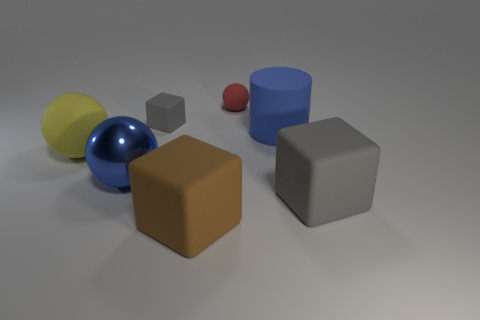Does the block that is to the right of the brown block have the same size as the tiny red rubber sphere?
Give a very brief answer. No. How many other objects are the same shape as the large brown thing?
Your response must be concise. 2. There is a ball that is to the right of the big brown matte block; is its color the same as the rubber cylinder?
Provide a succinct answer. No. Is there a large cylinder of the same color as the big metallic object?
Your answer should be very brief. Yes. There is a large brown matte block; how many blue objects are on the left side of it?
Keep it short and to the point. 1. What number of other objects are there of the same size as the yellow thing?
Your response must be concise. 4. Is the big blue thing right of the small rubber block made of the same material as the gray cube behind the large yellow matte object?
Offer a very short reply. Yes. There is a metallic object that is the same size as the matte cylinder; what is its color?
Give a very brief answer. Blue. Is there anything else that has the same color as the big rubber sphere?
Keep it short and to the point. No. There is a rubber sphere that is in front of the cube that is behind the gray matte thing on the right side of the big brown block; what is its size?
Your response must be concise. Large. 